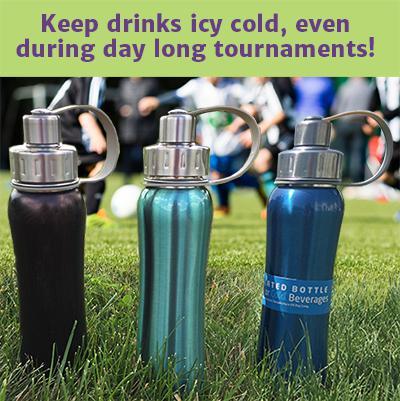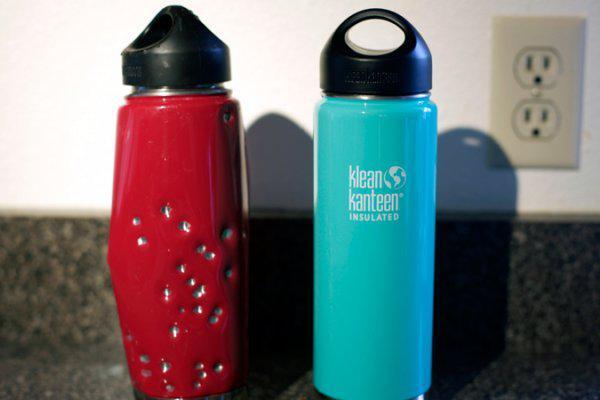The first image is the image on the left, the second image is the image on the right. Given the left and right images, does the statement "The bottles in one of the images are sitting outside." hold true? Answer yes or no. Yes. The first image is the image on the left, the second image is the image on the right. Considering the images on both sides, is "In one image, five bottles with chrome caps and dimpled bottom sections are the same design, but in different colors" valid? Answer yes or no. No. 